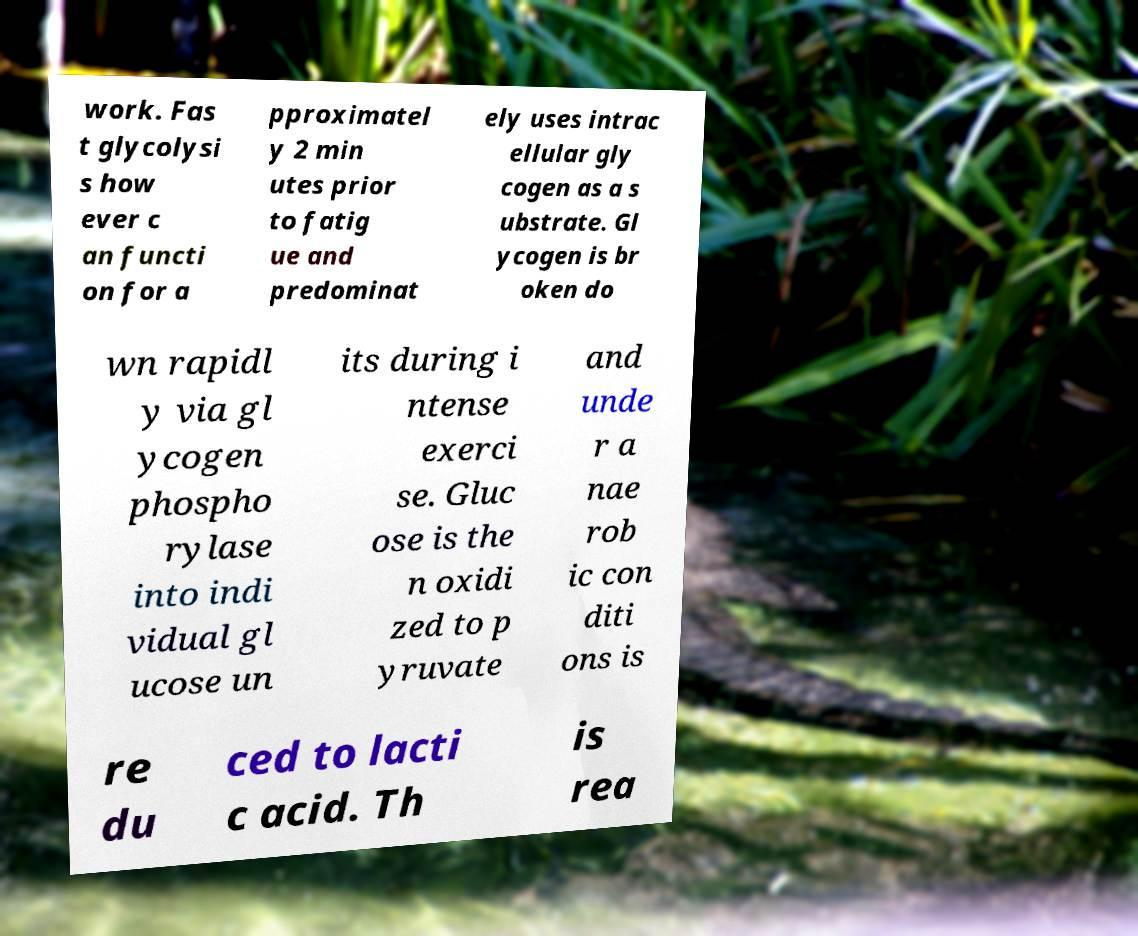Please identify and transcribe the text found in this image. work. Fas t glycolysi s how ever c an functi on for a pproximatel y 2 min utes prior to fatig ue and predominat ely uses intrac ellular gly cogen as a s ubstrate. Gl ycogen is br oken do wn rapidl y via gl ycogen phospho rylase into indi vidual gl ucose un its during i ntense exerci se. Gluc ose is the n oxidi zed to p yruvate and unde r a nae rob ic con diti ons is re du ced to lacti c acid. Th is rea 